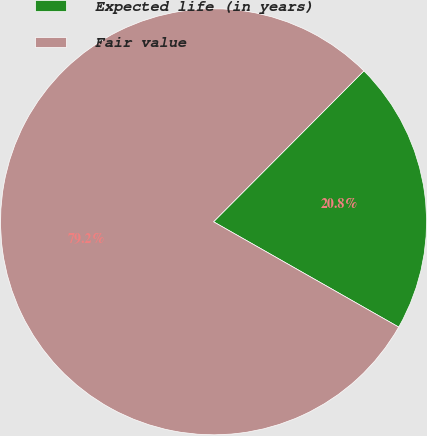<chart> <loc_0><loc_0><loc_500><loc_500><pie_chart><fcel>Expected life (in years)<fcel>Fair value<nl><fcel>20.76%<fcel>79.24%<nl></chart> 